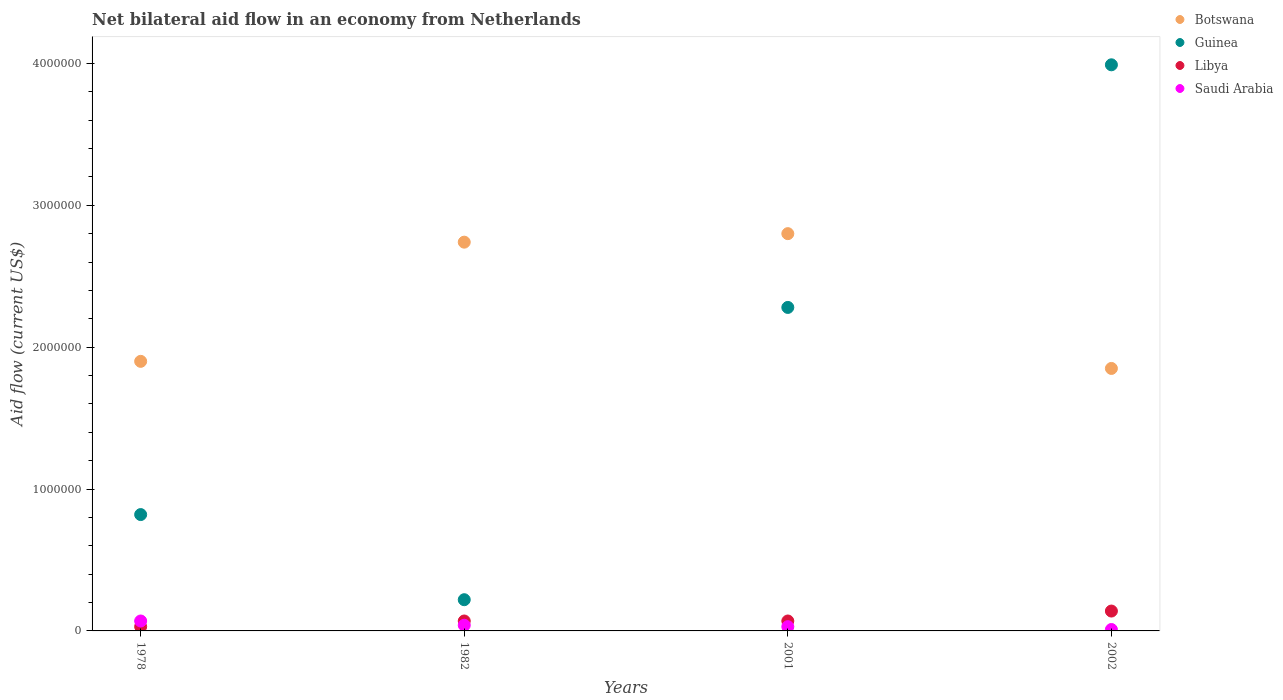How many different coloured dotlines are there?
Make the answer very short. 4. Is the number of dotlines equal to the number of legend labels?
Keep it short and to the point. Yes. What is the net bilateral aid flow in Guinea in 1978?
Ensure brevity in your answer.  8.20e+05. Across all years, what is the maximum net bilateral aid flow in Guinea?
Offer a terse response. 3.99e+06. Across all years, what is the minimum net bilateral aid flow in Botswana?
Keep it short and to the point. 1.85e+06. In which year was the net bilateral aid flow in Libya maximum?
Make the answer very short. 2002. In which year was the net bilateral aid flow in Saudi Arabia minimum?
Give a very brief answer. 2002. What is the total net bilateral aid flow in Botswana in the graph?
Your response must be concise. 9.29e+06. What is the difference between the net bilateral aid flow in Guinea in 1982 and that in 2002?
Your answer should be compact. -3.77e+06. What is the difference between the net bilateral aid flow in Botswana in 1978 and the net bilateral aid flow in Libya in 1982?
Offer a terse response. 1.83e+06. What is the average net bilateral aid flow in Guinea per year?
Make the answer very short. 1.83e+06. In the year 1982, what is the difference between the net bilateral aid flow in Libya and net bilateral aid flow in Guinea?
Provide a short and direct response. -1.50e+05. What is the ratio of the net bilateral aid flow in Libya in 1978 to that in 2001?
Your answer should be very brief. 0.43. Is the net bilateral aid flow in Saudi Arabia in 1982 less than that in 2001?
Provide a succinct answer. No. What is the difference between the highest and the second highest net bilateral aid flow in Guinea?
Provide a succinct answer. 1.71e+06. Does the net bilateral aid flow in Botswana monotonically increase over the years?
Your response must be concise. No. Is the net bilateral aid flow in Libya strictly less than the net bilateral aid flow in Saudi Arabia over the years?
Make the answer very short. No. How many years are there in the graph?
Give a very brief answer. 4. What is the difference between two consecutive major ticks on the Y-axis?
Your answer should be compact. 1.00e+06. Are the values on the major ticks of Y-axis written in scientific E-notation?
Your answer should be compact. No. Does the graph contain any zero values?
Provide a succinct answer. No. Does the graph contain grids?
Make the answer very short. No. Where does the legend appear in the graph?
Make the answer very short. Top right. How many legend labels are there?
Make the answer very short. 4. What is the title of the graph?
Give a very brief answer. Net bilateral aid flow in an economy from Netherlands. Does "Croatia" appear as one of the legend labels in the graph?
Provide a succinct answer. No. What is the label or title of the X-axis?
Offer a terse response. Years. What is the label or title of the Y-axis?
Offer a very short reply. Aid flow (current US$). What is the Aid flow (current US$) in Botswana in 1978?
Give a very brief answer. 1.90e+06. What is the Aid flow (current US$) of Guinea in 1978?
Your answer should be compact. 8.20e+05. What is the Aid flow (current US$) in Libya in 1978?
Your response must be concise. 3.00e+04. What is the Aid flow (current US$) in Saudi Arabia in 1978?
Make the answer very short. 7.00e+04. What is the Aid flow (current US$) in Botswana in 1982?
Your response must be concise. 2.74e+06. What is the Aid flow (current US$) in Botswana in 2001?
Keep it short and to the point. 2.80e+06. What is the Aid flow (current US$) of Guinea in 2001?
Give a very brief answer. 2.28e+06. What is the Aid flow (current US$) in Libya in 2001?
Your response must be concise. 7.00e+04. What is the Aid flow (current US$) of Botswana in 2002?
Make the answer very short. 1.85e+06. What is the Aid flow (current US$) in Guinea in 2002?
Make the answer very short. 3.99e+06. Across all years, what is the maximum Aid flow (current US$) of Botswana?
Keep it short and to the point. 2.80e+06. Across all years, what is the maximum Aid flow (current US$) of Guinea?
Offer a very short reply. 3.99e+06. Across all years, what is the maximum Aid flow (current US$) in Saudi Arabia?
Offer a terse response. 7.00e+04. Across all years, what is the minimum Aid flow (current US$) in Botswana?
Your response must be concise. 1.85e+06. What is the total Aid flow (current US$) in Botswana in the graph?
Your answer should be compact. 9.29e+06. What is the total Aid flow (current US$) in Guinea in the graph?
Offer a terse response. 7.31e+06. What is the difference between the Aid flow (current US$) of Botswana in 1978 and that in 1982?
Your answer should be compact. -8.40e+05. What is the difference between the Aid flow (current US$) in Guinea in 1978 and that in 1982?
Your answer should be compact. 6.00e+05. What is the difference between the Aid flow (current US$) in Botswana in 1978 and that in 2001?
Your response must be concise. -9.00e+05. What is the difference between the Aid flow (current US$) of Guinea in 1978 and that in 2001?
Offer a terse response. -1.46e+06. What is the difference between the Aid flow (current US$) of Saudi Arabia in 1978 and that in 2001?
Make the answer very short. 4.00e+04. What is the difference between the Aid flow (current US$) of Guinea in 1978 and that in 2002?
Offer a terse response. -3.17e+06. What is the difference between the Aid flow (current US$) in Saudi Arabia in 1978 and that in 2002?
Offer a terse response. 6.00e+04. What is the difference between the Aid flow (current US$) of Guinea in 1982 and that in 2001?
Give a very brief answer. -2.06e+06. What is the difference between the Aid flow (current US$) in Botswana in 1982 and that in 2002?
Your response must be concise. 8.90e+05. What is the difference between the Aid flow (current US$) in Guinea in 1982 and that in 2002?
Your response must be concise. -3.77e+06. What is the difference between the Aid flow (current US$) in Botswana in 2001 and that in 2002?
Ensure brevity in your answer.  9.50e+05. What is the difference between the Aid flow (current US$) in Guinea in 2001 and that in 2002?
Your answer should be compact. -1.71e+06. What is the difference between the Aid flow (current US$) in Saudi Arabia in 2001 and that in 2002?
Your answer should be compact. 2.00e+04. What is the difference between the Aid flow (current US$) of Botswana in 1978 and the Aid flow (current US$) of Guinea in 1982?
Offer a terse response. 1.68e+06. What is the difference between the Aid flow (current US$) of Botswana in 1978 and the Aid flow (current US$) of Libya in 1982?
Provide a succinct answer. 1.83e+06. What is the difference between the Aid flow (current US$) of Botswana in 1978 and the Aid flow (current US$) of Saudi Arabia in 1982?
Give a very brief answer. 1.86e+06. What is the difference between the Aid flow (current US$) of Guinea in 1978 and the Aid flow (current US$) of Libya in 1982?
Give a very brief answer. 7.50e+05. What is the difference between the Aid flow (current US$) of Guinea in 1978 and the Aid flow (current US$) of Saudi Arabia in 1982?
Offer a terse response. 7.80e+05. What is the difference between the Aid flow (current US$) of Botswana in 1978 and the Aid flow (current US$) of Guinea in 2001?
Provide a succinct answer. -3.80e+05. What is the difference between the Aid flow (current US$) in Botswana in 1978 and the Aid flow (current US$) in Libya in 2001?
Your answer should be compact. 1.83e+06. What is the difference between the Aid flow (current US$) in Botswana in 1978 and the Aid flow (current US$) in Saudi Arabia in 2001?
Provide a succinct answer. 1.87e+06. What is the difference between the Aid flow (current US$) of Guinea in 1978 and the Aid flow (current US$) of Libya in 2001?
Provide a succinct answer. 7.50e+05. What is the difference between the Aid flow (current US$) in Guinea in 1978 and the Aid flow (current US$) in Saudi Arabia in 2001?
Make the answer very short. 7.90e+05. What is the difference between the Aid flow (current US$) of Libya in 1978 and the Aid flow (current US$) of Saudi Arabia in 2001?
Ensure brevity in your answer.  0. What is the difference between the Aid flow (current US$) in Botswana in 1978 and the Aid flow (current US$) in Guinea in 2002?
Provide a short and direct response. -2.09e+06. What is the difference between the Aid flow (current US$) of Botswana in 1978 and the Aid flow (current US$) of Libya in 2002?
Your answer should be very brief. 1.76e+06. What is the difference between the Aid flow (current US$) in Botswana in 1978 and the Aid flow (current US$) in Saudi Arabia in 2002?
Your answer should be compact. 1.89e+06. What is the difference between the Aid flow (current US$) in Guinea in 1978 and the Aid flow (current US$) in Libya in 2002?
Offer a terse response. 6.80e+05. What is the difference between the Aid flow (current US$) of Guinea in 1978 and the Aid flow (current US$) of Saudi Arabia in 2002?
Your response must be concise. 8.10e+05. What is the difference between the Aid flow (current US$) of Botswana in 1982 and the Aid flow (current US$) of Libya in 2001?
Give a very brief answer. 2.67e+06. What is the difference between the Aid flow (current US$) of Botswana in 1982 and the Aid flow (current US$) of Saudi Arabia in 2001?
Offer a very short reply. 2.71e+06. What is the difference between the Aid flow (current US$) in Botswana in 1982 and the Aid flow (current US$) in Guinea in 2002?
Make the answer very short. -1.25e+06. What is the difference between the Aid flow (current US$) in Botswana in 1982 and the Aid flow (current US$) in Libya in 2002?
Your response must be concise. 2.60e+06. What is the difference between the Aid flow (current US$) of Botswana in 1982 and the Aid flow (current US$) of Saudi Arabia in 2002?
Your answer should be very brief. 2.73e+06. What is the difference between the Aid flow (current US$) of Guinea in 1982 and the Aid flow (current US$) of Libya in 2002?
Make the answer very short. 8.00e+04. What is the difference between the Aid flow (current US$) in Libya in 1982 and the Aid flow (current US$) in Saudi Arabia in 2002?
Make the answer very short. 6.00e+04. What is the difference between the Aid flow (current US$) in Botswana in 2001 and the Aid flow (current US$) in Guinea in 2002?
Offer a terse response. -1.19e+06. What is the difference between the Aid flow (current US$) in Botswana in 2001 and the Aid flow (current US$) in Libya in 2002?
Offer a very short reply. 2.66e+06. What is the difference between the Aid flow (current US$) of Botswana in 2001 and the Aid flow (current US$) of Saudi Arabia in 2002?
Provide a succinct answer. 2.79e+06. What is the difference between the Aid flow (current US$) of Guinea in 2001 and the Aid flow (current US$) of Libya in 2002?
Provide a succinct answer. 2.14e+06. What is the difference between the Aid flow (current US$) of Guinea in 2001 and the Aid flow (current US$) of Saudi Arabia in 2002?
Offer a very short reply. 2.27e+06. What is the difference between the Aid flow (current US$) in Libya in 2001 and the Aid flow (current US$) in Saudi Arabia in 2002?
Offer a terse response. 6.00e+04. What is the average Aid flow (current US$) of Botswana per year?
Offer a terse response. 2.32e+06. What is the average Aid flow (current US$) in Guinea per year?
Offer a terse response. 1.83e+06. What is the average Aid flow (current US$) in Libya per year?
Your response must be concise. 7.75e+04. What is the average Aid flow (current US$) of Saudi Arabia per year?
Provide a succinct answer. 3.75e+04. In the year 1978, what is the difference between the Aid flow (current US$) of Botswana and Aid flow (current US$) of Guinea?
Provide a succinct answer. 1.08e+06. In the year 1978, what is the difference between the Aid flow (current US$) of Botswana and Aid flow (current US$) of Libya?
Keep it short and to the point. 1.87e+06. In the year 1978, what is the difference between the Aid flow (current US$) of Botswana and Aid flow (current US$) of Saudi Arabia?
Your answer should be very brief. 1.83e+06. In the year 1978, what is the difference between the Aid flow (current US$) in Guinea and Aid flow (current US$) in Libya?
Your response must be concise. 7.90e+05. In the year 1978, what is the difference between the Aid flow (current US$) of Guinea and Aid flow (current US$) of Saudi Arabia?
Your answer should be compact. 7.50e+05. In the year 1978, what is the difference between the Aid flow (current US$) in Libya and Aid flow (current US$) in Saudi Arabia?
Your answer should be compact. -4.00e+04. In the year 1982, what is the difference between the Aid flow (current US$) of Botswana and Aid flow (current US$) of Guinea?
Your answer should be compact. 2.52e+06. In the year 1982, what is the difference between the Aid flow (current US$) in Botswana and Aid flow (current US$) in Libya?
Give a very brief answer. 2.67e+06. In the year 1982, what is the difference between the Aid flow (current US$) in Botswana and Aid flow (current US$) in Saudi Arabia?
Provide a succinct answer. 2.70e+06. In the year 1982, what is the difference between the Aid flow (current US$) in Guinea and Aid flow (current US$) in Saudi Arabia?
Your response must be concise. 1.80e+05. In the year 1982, what is the difference between the Aid flow (current US$) in Libya and Aid flow (current US$) in Saudi Arabia?
Keep it short and to the point. 3.00e+04. In the year 2001, what is the difference between the Aid flow (current US$) in Botswana and Aid flow (current US$) in Guinea?
Keep it short and to the point. 5.20e+05. In the year 2001, what is the difference between the Aid flow (current US$) of Botswana and Aid flow (current US$) of Libya?
Offer a very short reply. 2.73e+06. In the year 2001, what is the difference between the Aid flow (current US$) in Botswana and Aid flow (current US$) in Saudi Arabia?
Your answer should be compact. 2.77e+06. In the year 2001, what is the difference between the Aid flow (current US$) of Guinea and Aid flow (current US$) of Libya?
Give a very brief answer. 2.21e+06. In the year 2001, what is the difference between the Aid flow (current US$) in Guinea and Aid flow (current US$) in Saudi Arabia?
Offer a terse response. 2.25e+06. In the year 2001, what is the difference between the Aid flow (current US$) of Libya and Aid flow (current US$) of Saudi Arabia?
Provide a short and direct response. 4.00e+04. In the year 2002, what is the difference between the Aid flow (current US$) of Botswana and Aid flow (current US$) of Guinea?
Provide a succinct answer. -2.14e+06. In the year 2002, what is the difference between the Aid flow (current US$) of Botswana and Aid flow (current US$) of Libya?
Your answer should be compact. 1.71e+06. In the year 2002, what is the difference between the Aid flow (current US$) of Botswana and Aid flow (current US$) of Saudi Arabia?
Make the answer very short. 1.84e+06. In the year 2002, what is the difference between the Aid flow (current US$) in Guinea and Aid flow (current US$) in Libya?
Provide a short and direct response. 3.85e+06. In the year 2002, what is the difference between the Aid flow (current US$) in Guinea and Aid flow (current US$) in Saudi Arabia?
Ensure brevity in your answer.  3.98e+06. What is the ratio of the Aid flow (current US$) in Botswana in 1978 to that in 1982?
Make the answer very short. 0.69. What is the ratio of the Aid flow (current US$) in Guinea in 1978 to that in 1982?
Provide a short and direct response. 3.73. What is the ratio of the Aid flow (current US$) of Libya in 1978 to that in 1982?
Give a very brief answer. 0.43. What is the ratio of the Aid flow (current US$) in Botswana in 1978 to that in 2001?
Offer a very short reply. 0.68. What is the ratio of the Aid flow (current US$) in Guinea in 1978 to that in 2001?
Keep it short and to the point. 0.36. What is the ratio of the Aid flow (current US$) in Libya in 1978 to that in 2001?
Ensure brevity in your answer.  0.43. What is the ratio of the Aid flow (current US$) of Saudi Arabia in 1978 to that in 2001?
Your response must be concise. 2.33. What is the ratio of the Aid flow (current US$) in Guinea in 1978 to that in 2002?
Your answer should be compact. 0.21. What is the ratio of the Aid flow (current US$) of Libya in 1978 to that in 2002?
Give a very brief answer. 0.21. What is the ratio of the Aid flow (current US$) of Saudi Arabia in 1978 to that in 2002?
Offer a terse response. 7. What is the ratio of the Aid flow (current US$) of Botswana in 1982 to that in 2001?
Provide a succinct answer. 0.98. What is the ratio of the Aid flow (current US$) of Guinea in 1982 to that in 2001?
Provide a short and direct response. 0.1. What is the ratio of the Aid flow (current US$) of Libya in 1982 to that in 2001?
Make the answer very short. 1. What is the ratio of the Aid flow (current US$) in Saudi Arabia in 1982 to that in 2001?
Provide a short and direct response. 1.33. What is the ratio of the Aid flow (current US$) of Botswana in 1982 to that in 2002?
Provide a short and direct response. 1.48. What is the ratio of the Aid flow (current US$) of Guinea in 1982 to that in 2002?
Your answer should be compact. 0.06. What is the ratio of the Aid flow (current US$) in Libya in 1982 to that in 2002?
Ensure brevity in your answer.  0.5. What is the ratio of the Aid flow (current US$) in Botswana in 2001 to that in 2002?
Offer a very short reply. 1.51. What is the difference between the highest and the second highest Aid flow (current US$) of Guinea?
Your response must be concise. 1.71e+06. What is the difference between the highest and the lowest Aid flow (current US$) of Botswana?
Offer a terse response. 9.50e+05. What is the difference between the highest and the lowest Aid flow (current US$) in Guinea?
Provide a succinct answer. 3.77e+06. What is the difference between the highest and the lowest Aid flow (current US$) in Libya?
Your response must be concise. 1.10e+05. What is the difference between the highest and the lowest Aid flow (current US$) of Saudi Arabia?
Your answer should be compact. 6.00e+04. 